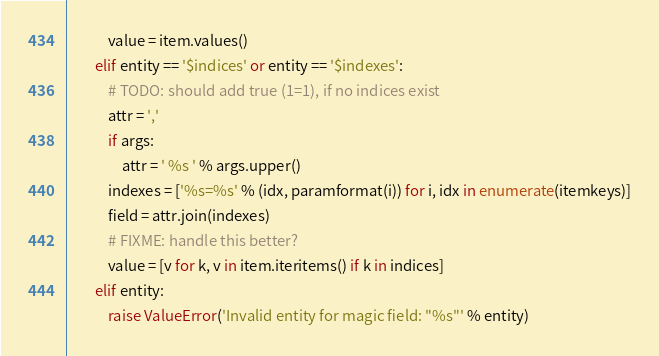Convert code to text. <code><loc_0><loc_0><loc_500><loc_500><_Python_>			value = item.values()
		elif entity == '$indices' or entity == '$indexes':
			# TODO: should add true (1=1), if no indices exist
			attr = ','
			if args:
				attr = ' %s ' % args.upper()
			indexes = ['%s=%s' % (idx, paramformat(i)) for i, idx in enumerate(itemkeys)]
			field = attr.join(indexes)
			# FIXME: handle this better?
			value = [v for k, v in item.iteritems() if k in indices]
		elif entity:
			raise ValueError('Invalid entity for magic field: "%s"' % entity)
</code> 